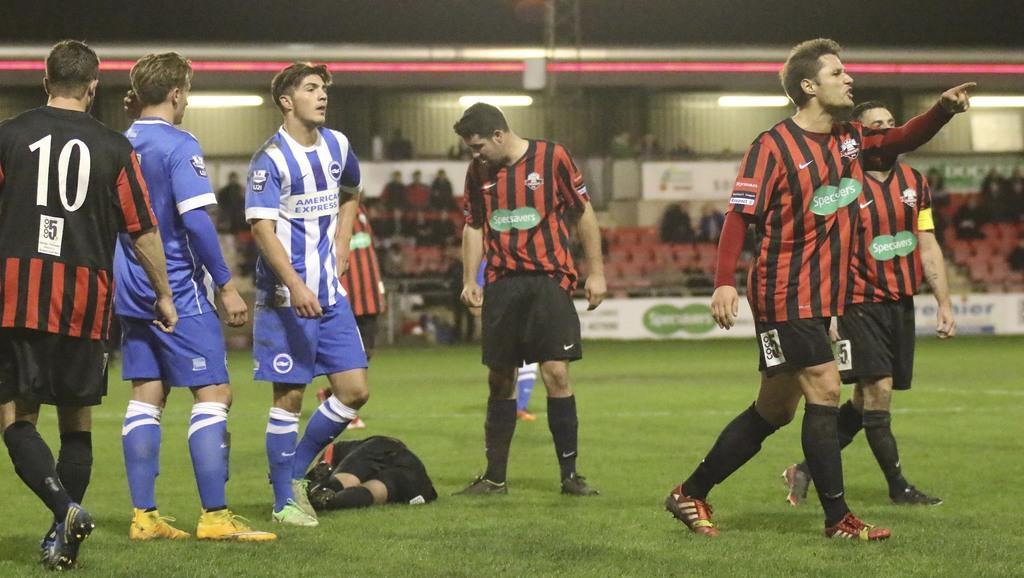Can you describe this image briefly? This picture shows a few players playing on the ground and on the green field and we see a player laying down on the ground and we see people seated and watching the game and we see lights. 